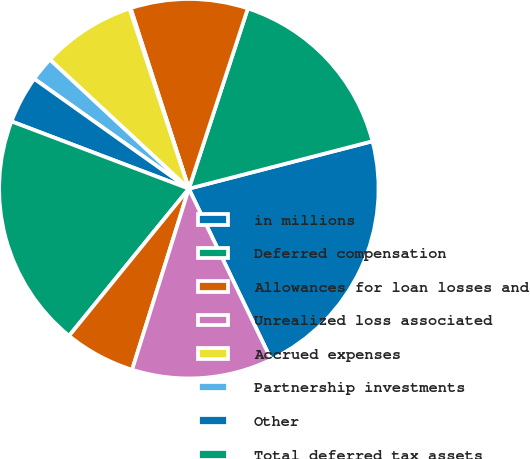<chart> <loc_0><loc_0><loc_500><loc_500><pie_chart><fcel>in millions<fcel>Deferred compensation<fcel>Allowances for loan losses and<fcel>Unrealized loss associated<fcel>Accrued expenses<fcel>Partnership investments<fcel>Other<fcel>Total deferred tax assets<fcel>Goodwill and identifiable<fcel>Property and equipment<nl><fcel>21.88%<fcel>15.94%<fcel>10.0%<fcel>0.1%<fcel>8.02%<fcel>2.08%<fcel>4.06%<fcel>19.9%<fcel>6.04%<fcel>11.98%<nl></chart> 